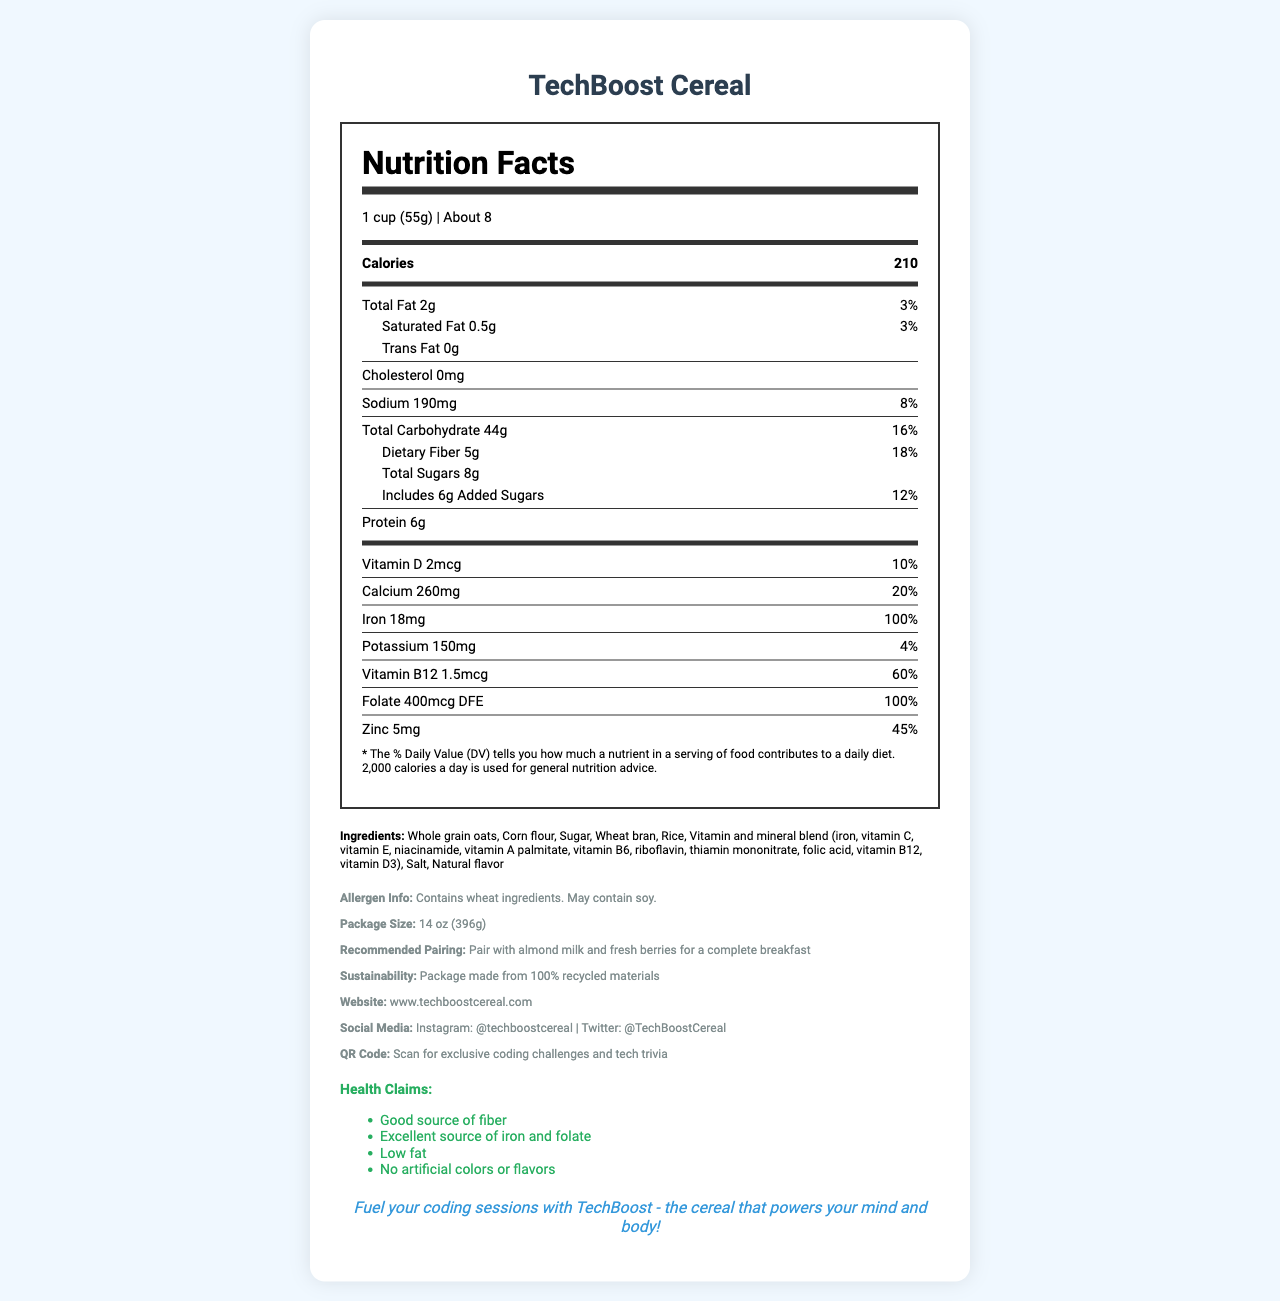What is the serving size of TechBoost Cereal? The serving size is clearly stated at the beginning of the Nutrition Facts section: "1 cup (55g)".
Answer: 1 cup (55g) How many servings are in one container of TechBoost Cereal? The servings per container are listed under the serving size: "About 8".
Answer: About 8 What is the amount of dietary fiber in one serving of TechBoost Cereal? The dietary fiber amount is listed under total carbohydrates: "Dietary Fiber 5g".
Answer: 5g How many calories does one serving of TechBoost Cereal contain? The calories are prominently displayed at the beginning of the Nutrition Facts: "Calories 210".
Answer: 210 Which vitamins and minerals are included in the vitamin and mineral blend? This information is found in the ingredients list where it specifies: "Vitamin and mineral blend (iron, vitamin C, vitamin E, niacinamide, vitamin A palmitate, vitamin B6, riboflavin, thiamin mononitrate, folic acid, vitamin B12, vitamin D3)".
Answer: Iron, vitamin C, vitamin E, niacinamide, vitamin A palmitate, vitamin B6, riboflavin, thiamin mononitrate, folic acid, vitamin B12, vitamin D3 What is the % Daily Value of Vitamin B12 provided by one serving of TechBoost Cereal?
A. 10% 
B. 20% 
C. 60% 
D. 100% The % Daily Value for Vitamin B12 is explicitly listed in the Nutrition Facts section: "Vitamin B12 60%".
Answer: C How much calcium is present in each serving, and what percentage of the daily value does it represent?
A) 260mg, 10%
B) 260mg, 20%
C) 2mcg, 10%
D) 2mcg, 20% The Nutrition Facts indicate: "Calcium 260mg" and "20%".
Answer: B) 260mg, 20% Does TechBoost Cereal contain any artificial colors or flavors? This is stated under the health claims: "No artificial colors or flavors".
Answer: No Summarize the main nutritional benefits of TechBoost Cereal. The document’s nutrition facts, health claims, and marketing tagline provide a comprehensive overview of the cereal's nutritional benefits and target audience.
Answer: TechBoost Cereal is a low-fat, vitamin-fortified breakfast cereal that is high in fiber and rich in vitamins and minerals such as iron, folate, and Vitamin B12. It contains no artificial colors or flavors and is marketed towards health-conscious millennials in the tech field. How much total fat is in one serving of TechBoost Cereal? The total fat content is listed under the Total Fat section: "Total Fat 2g".
Answer: 2g Is TechBoost Cereal a good source of fiber? One of the health claims states: "Good source of fiber."
Answer: Yes What are the allergens mentioned for TechBoost Cereal? The allergen information section lists: "Contains wheat ingredients. May contain soy."
Answer: Wheat ingredients, may contain soy What is the website for more information about TechBoost Cereal? The website information is provided in the additional info section: "www.techboostcereal.com".
Answer: www.techboostcereal.com What other foods does TechBoost Cereal recommend pairing with? The recommended pairing section suggests: "Pair with almond milk and fresh berries for a complete breakfast".
Answer: Almond milk and fresh berries What sustainability information is provided for TechBoost Cereal? The document states in the sustainability info section: "Package made from 100% recycled materials".
Answer: Package made from 100% recycled materials Is this product suitable for someone with a soy allergy? The allergen info lists "Contains wheat ingredients. May contain soy.", which means it could potentially have soy, making it unclear if it is safe for someone with a soy allergy.
Answer: Cannot be determined 